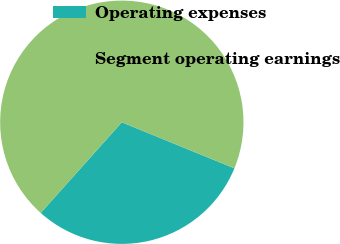<chart> <loc_0><loc_0><loc_500><loc_500><pie_chart><fcel>Operating expenses<fcel>Segment operating earnings<nl><fcel>30.43%<fcel>69.57%<nl></chart> 